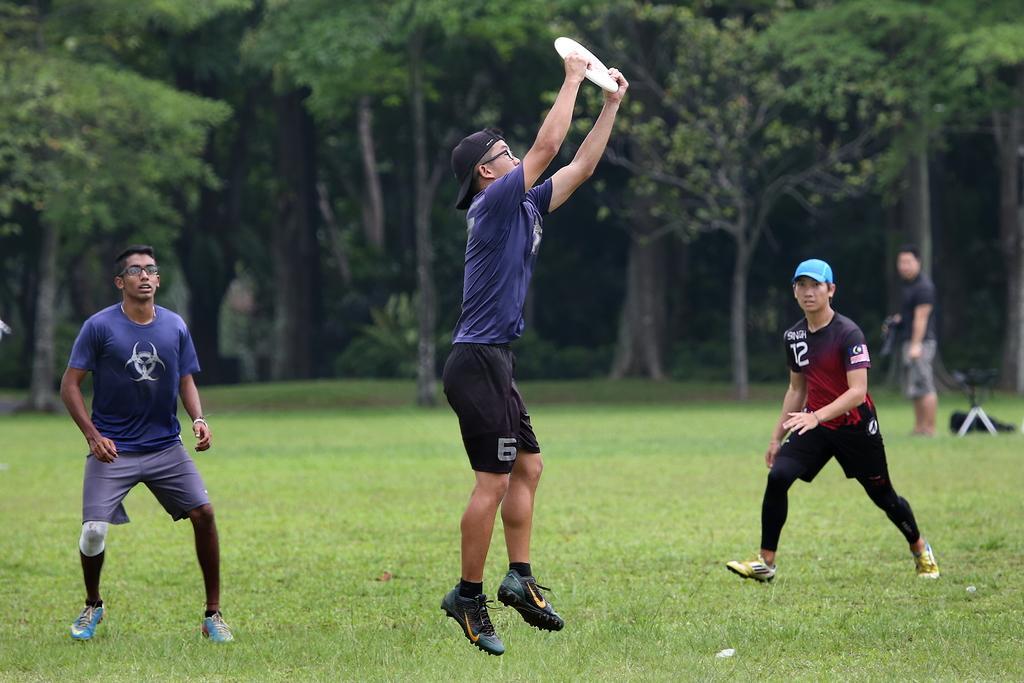Describe this image in one or two sentences. In this picture there is a man who is wearing cap, t-shirt, short and shoe. He is jumping to catch a white plate. On the left there is another man who is wearing blue t-shirt, spectacle, short and shoe. On the right there is a man who is wearing blue cap, t-shirt, short and shoe. He is running on the ground. In the background we can see many trees and plants. On the right background there is another man who is standing near the bag and chair. At the bottom we can see the green grass. 